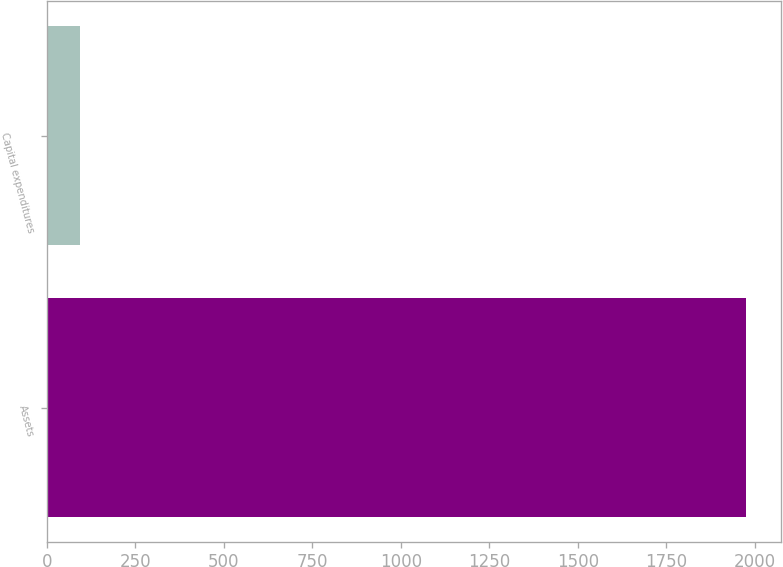Convert chart to OTSL. <chart><loc_0><loc_0><loc_500><loc_500><bar_chart><fcel>Assets<fcel>Capital expenditures<nl><fcel>1976<fcel>95<nl></chart> 